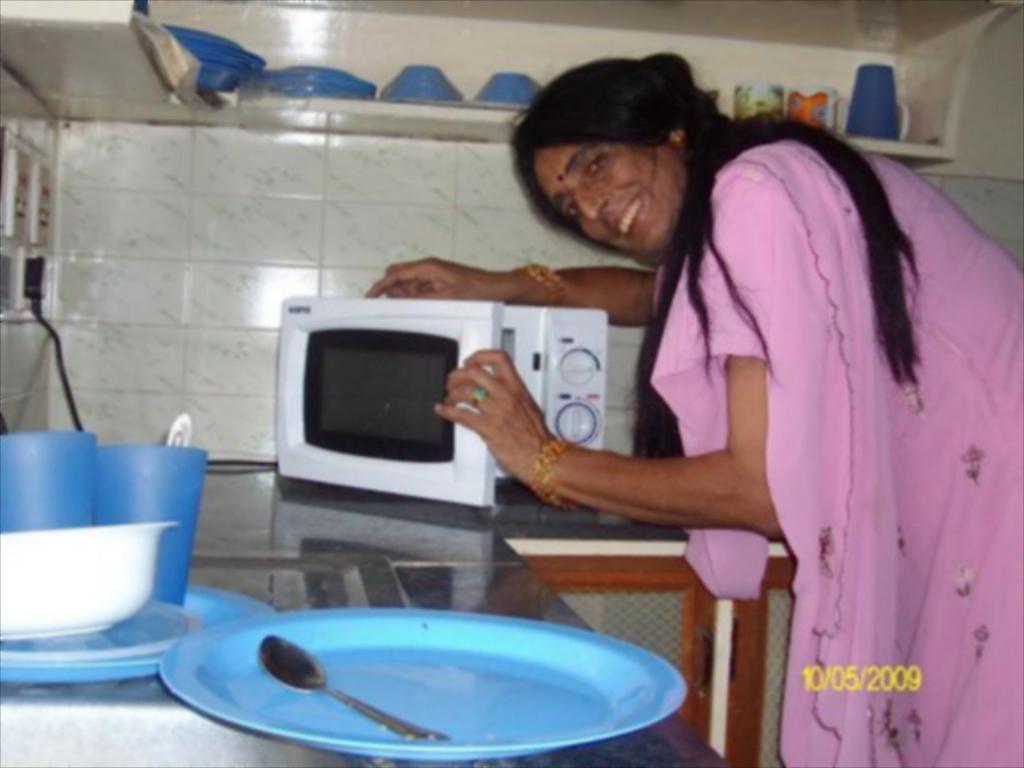In one or two sentences, can you explain what this image depicts? In this picture we can see a woman standing and smiling, microwave oven, plates, glass, spoon, bowl, switchboard, wall, cupboards, shelf with cups and some objects on it. 